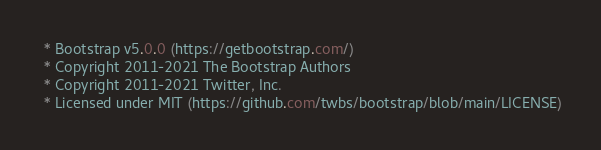<code> <loc_0><loc_0><loc_500><loc_500><_CSS_> * Bootstrap v5.0.0 (https://getbootstrap.com/)
 * Copyright 2011-2021 The Bootstrap Authors
 * Copyright 2011-2021 Twitter, Inc.
 * Licensed under MIT (https://github.com/twbs/bootstrap/blob/main/LICENSE)</code> 